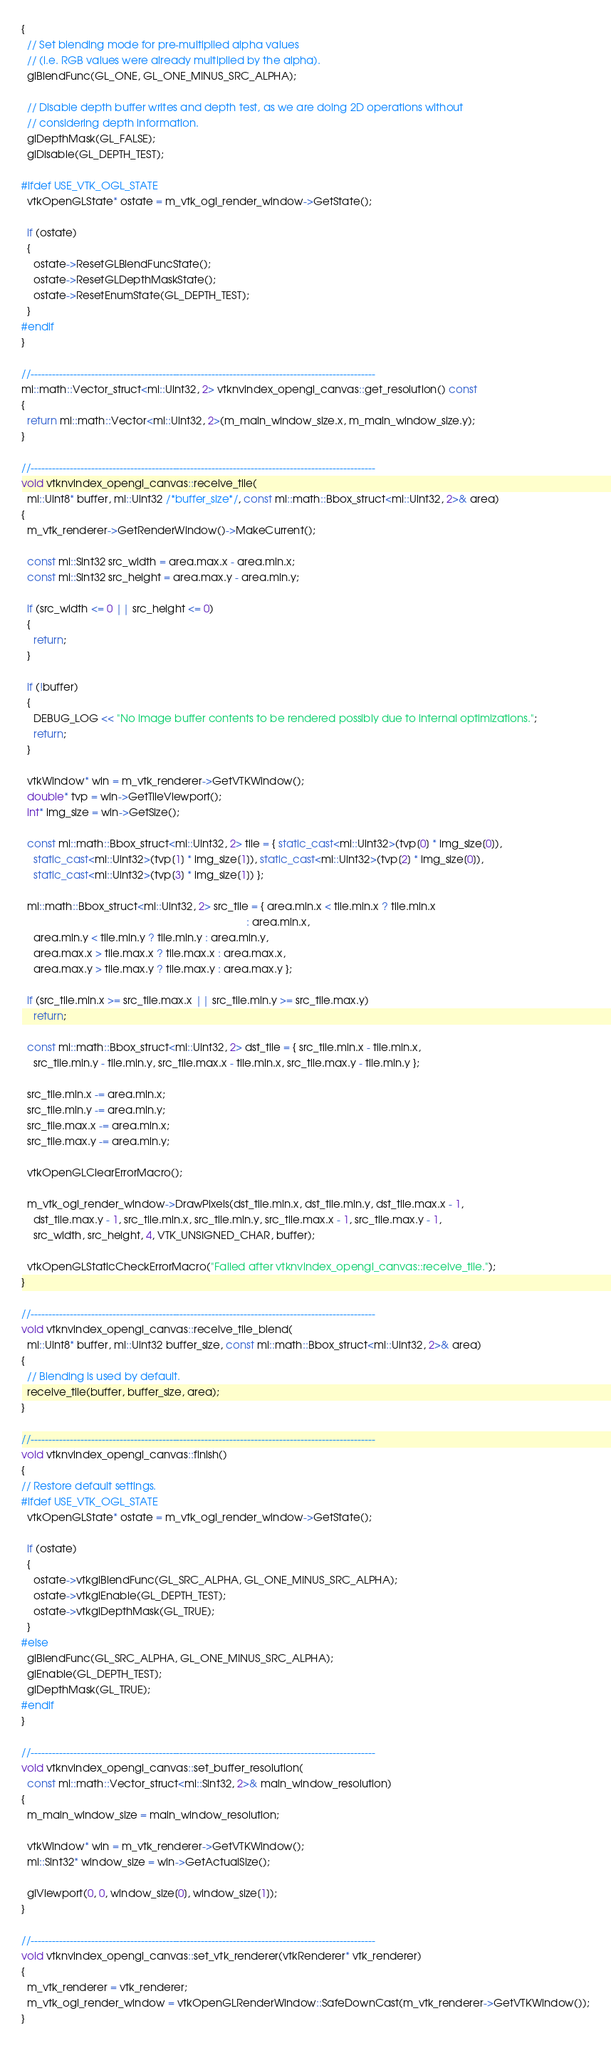Convert code to text. <code><loc_0><loc_0><loc_500><loc_500><_C++_>{
  // Set blending mode for pre-multiplied alpha values
  // (i.e. RGB values were already multiplied by the alpha).
  glBlendFunc(GL_ONE, GL_ONE_MINUS_SRC_ALPHA);

  // Disable depth buffer writes and depth test, as we are doing 2D operations without
  // considering depth information.
  glDepthMask(GL_FALSE);
  glDisable(GL_DEPTH_TEST);

#ifdef USE_VTK_OGL_STATE
  vtkOpenGLState* ostate = m_vtk_ogl_render_window->GetState();

  if (ostate)
  {
    ostate->ResetGLBlendFuncState();
    ostate->ResetGLDepthMaskState();
    ostate->ResetEnumState(GL_DEPTH_TEST);
  }
#endif
}

//-------------------------------------------------------------------------------------------------
mi::math::Vector_struct<mi::Uint32, 2> vtknvindex_opengl_canvas::get_resolution() const
{
  return mi::math::Vector<mi::Uint32, 2>(m_main_window_size.x, m_main_window_size.y);
}

//-------------------------------------------------------------------------------------------------
void vtknvindex_opengl_canvas::receive_tile(
  mi::Uint8* buffer, mi::Uint32 /*buffer_size*/, const mi::math::Bbox_struct<mi::Uint32, 2>& area)
{
  m_vtk_renderer->GetRenderWindow()->MakeCurrent();

  const mi::Sint32 src_width = area.max.x - area.min.x;
  const mi::Sint32 src_height = area.max.y - area.min.y;

  if (src_width <= 0 || src_height <= 0)
  {
    return;
  }

  if (!buffer)
  {
    DEBUG_LOG << "No image buffer contents to be rendered possibly due to internal optimizations.";
    return;
  }

  vtkWindow* win = m_vtk_renderer->GetVTKWindow();
  double* tvp = win->GetTileViewport();
  int* img_size = win->GetSize();

  const mi::math::Bbox_struct<mi::Uint32, 2> tile = { static_cast<mi::Uint32>(tvp[0] * img_size[0]),
    static_cast<mi::Uint32>(tvp[1] * img_size[1]), static_cast<mi::Uint32>(tvp[2] * img_size[0]),
    static_cast<mi::Uint32>(tvp[3] * img_size[1]) };

  mi::math::Bbox_struct<mi::Uint32, 2> src_tile = { area.min.x < tile.min.x ? tile.min.x
                                                                            : area.min.x,
    area.min.y < tile.min.y ? tile.min.y : area.min.y,
    area.max.x > tile.max.x ? tile.max.x : area.max.x,
    area.max.y > tile.max.y ? tile.max.y : area.max.y };

  if (src_tile.min.x >= src_tile.max.x || src_tile.min.y >= src_tile.max.y)
    return;

  const mi::math::Bbox_struct<mi::Uint32, 2> dst_tile = { src_tile.min.x - tile.min.x,
    src_tile.min.y - tile.min.y, src_tile.max.x - tile.min.x, src_tile.max.y - tile.min.y };

  src_tile.min.x -= area.min.x;
  src_tile.min.y -= area.min.y;
  src_tile.max.x -= area.min.x;
  src_tile.max.y -= area.min.y;

  vtkOpenGLClearErrorMacro();

  m_vtk_ogl_render_window->DrawPixels(dst_tile.min.x, dst_tile.min.y, dst_tile.max.x - 1,
    dst_tile.max.y - 1, src_tile.min.x, src_tile.min.y, src_tile.max.x - 1, src_tile.max.y - 1,
    src_width, src_height, 4, VTK_UNSIGNED_CHAR, buffer);

  vtkOpenGLStaticCheckErrorMacro("Failed after vtknvindex_opengl_canvas::receive_tile.");
}

//-------------------------------------------------------------------------------------------------
void vtknvindex_opengl_canvas::receive_tile_blend(
  mi::Uint8* buffer, mi::Uint32 buffer_size, const mi::math::Bbox_struct<mi::Uint32, 2>& area)
{
  // Blending is used by default.
  receive_tile(buffer, buffer_size, area);
}

//-------------------------------------------------------------------------------------------------
void vtknvindex_opengl_canvas::finish()
{
// Restore default settings.
#ifdef USE_VTK_OGL_STATE
  vtkOpenGLState* ostate = m_vtk_ogl_render_window->GetState();

  if (ostate)
  {
    ostate->vtkglBlendFunc(GL_SRC_ALPHA, GL_ONE_MINUS_SRC_ALPHA);
    ostate->vtkglEnable(GL_DEPTH_TEST);
    ostate->vtkglDepthMask(GL_TRUE);
  }
#else
  glBlendFunc(GL_SRC_ALPHA, GL_ONE_MINUS_SRC_ALPHA);
  glEnable(GL_DEPTH_TEST);
  glDepthMask(GL_TRUE);
#endif
}

//-------------------------------------------------------------------------------------------------
void vtknvindex_opengl_canvas::set_buffer_resolution(
  const mi::math::Vector_struct<mi::Sint32, 2>& main_window_resolution)
{
  m_main_window_size = main_window_resolution;

  vtkWindow* win = m_vtk_renderer->GetVTKWindow();
  mi::Sint32* window_size = win->GetActualSize();

  glViewport(0, 0, window_size[0], window_size[1]);
}

//-------------------------------------------------------------------------------------------------
void vtknvindex_opengl_canvas::set_vtk_renderer(vtkRenderer* vtk_renderer)
{
  m_vtk_renderer = vtk_renderer;
  m_vtk_ogl_render_window = vtkOpenGLRenderWindow::SafeDownCast(m_vtk_renderer->GetVTKWindow());
}
</code> 